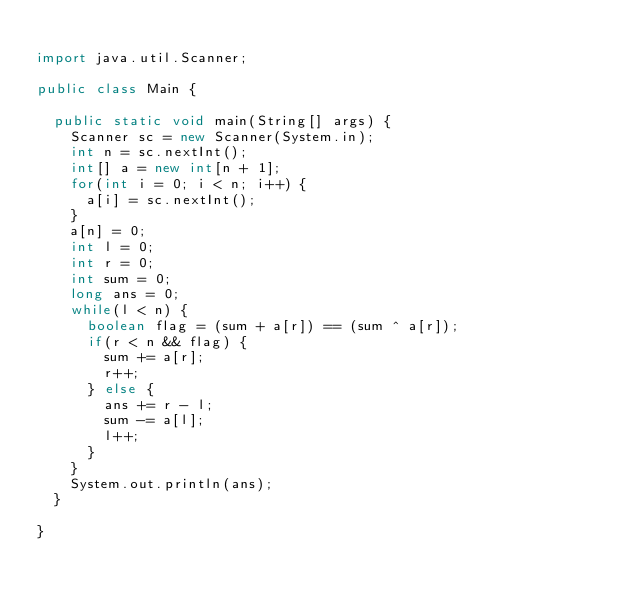Convert code to text. <code><loc_0><loc_0><loc_500><loc_500><_Java_>
import java.util.Scanner;

public class Main {

	public static void main(String[] args) {
		Scanner sc = new Scanner(System.in);
		int n = sc.nextInt();
		int[] a = new int[n + 1];
		for(int i = 0; i < n; i++) {
			a[i] = sc.nextInt();
		}
		a[n] = 0;
		int l = 0;
		int r = 0;
		int sum = 0;
		long ans = 0;
		while(l < n) {
			boolean flag = (sum + a[r]) == (sum ^ a[r]);
			if(r < n && flag) {
				sum += a[r];
				r++;
			} else {
				ans += r - l;
				sum -= a[l];
				l++;
			}
		}
		System.out.println(ans);
	}

}
</code> 